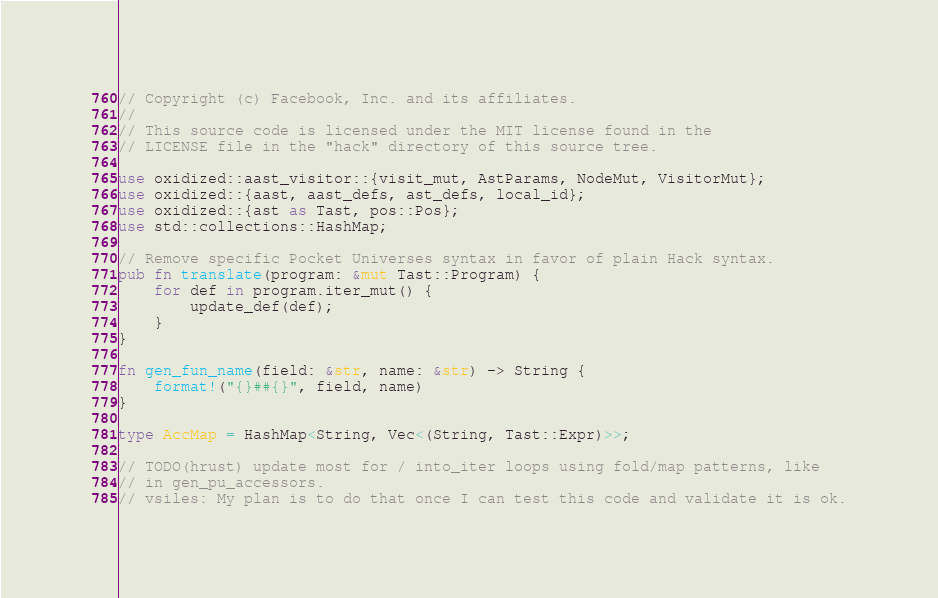<code> <loc_0><loc_0><loc_500><loc_500><_Rust_>// Copyright (c) Facebook, Inc. and its affiliates.
//
// This source code is licensed under the MIT license found in the
// LICENSE file in the "hack" directory of this source tree.

use oxidized::aast_visitor::{visit_mut, AstParams, NodeMut, VisitorMut};
use oxidized::{aast, aast_defs, ast_defs, local_id};
use oxidized::{ast as Tast, pos::Pos};
use std::collections::HashMap;

// Remove specific Pocket Universes syntax in favor of plain Hack syntax.
pub fn translate(program: &mut Tast::Program) {
    for def in program.iter_mut() {
        update_def(def);
    }
}

fn gen_fun_name(field: &str, name: &str) -> String {
    format!("{}##{}", field, name)
}

type AccMap = HashMap<String, Vec<(String, Tast::Expr)>>;

// TODO(hrust) update most for / into_iter loops using fold/map patterns, like
// in gen_pu_accessors.
// vsiles: My plan is to do that once I can test this code and validate it is ok.
</code> 